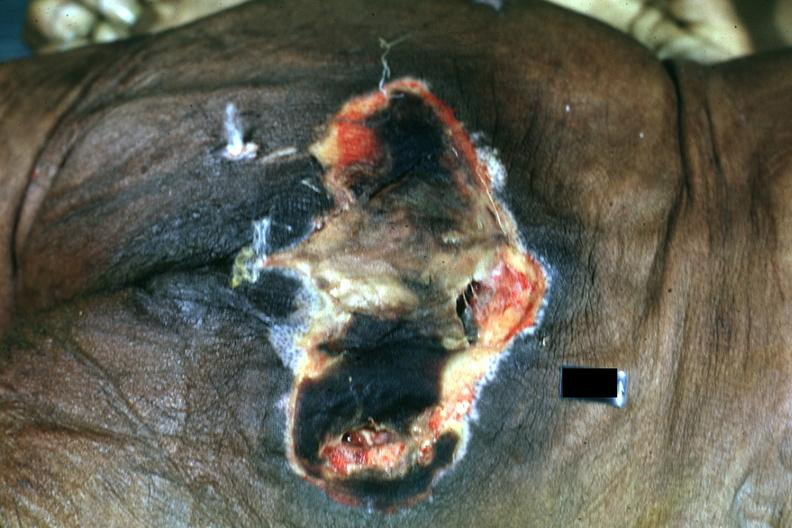where is this?
Answer the question using a single word or phrase. Skin 